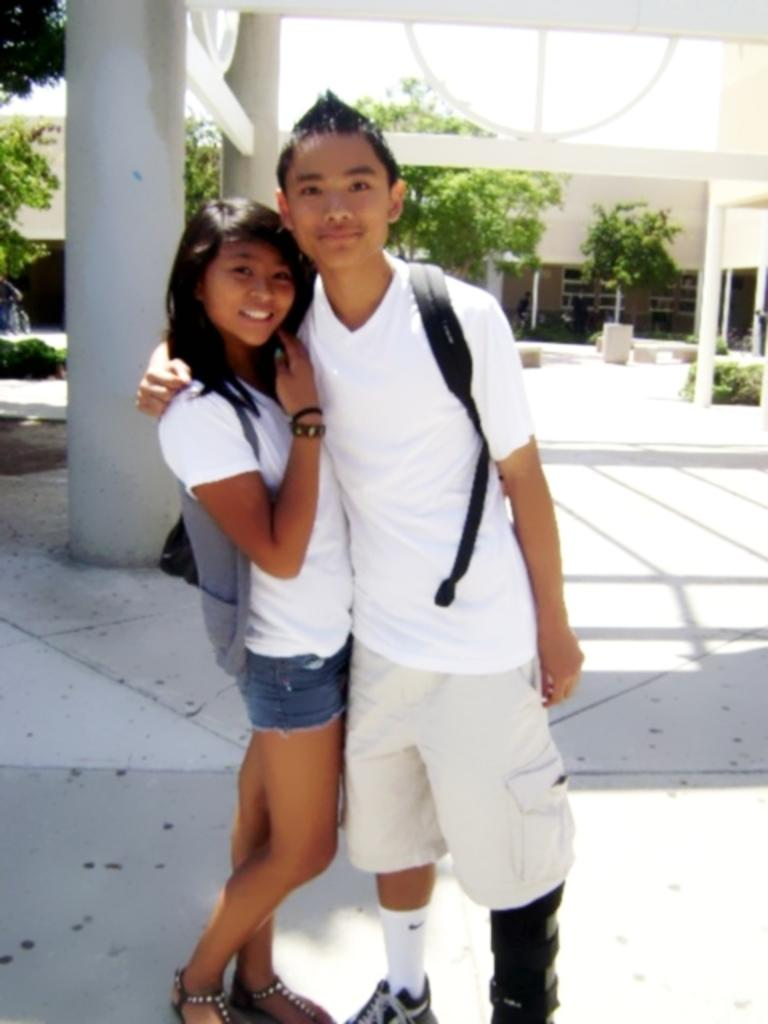How many people are in the image? There are two people in the image. What are the people doing in the image? The people are standing on the ground and smiling. What can be seen in the background of the image? There are pillars and trees in the background of the image. What type of vacation is the couple planning based on the image? There is no indication in the image that the couple is planning a vacation, so it cannot be determined from the picture. 